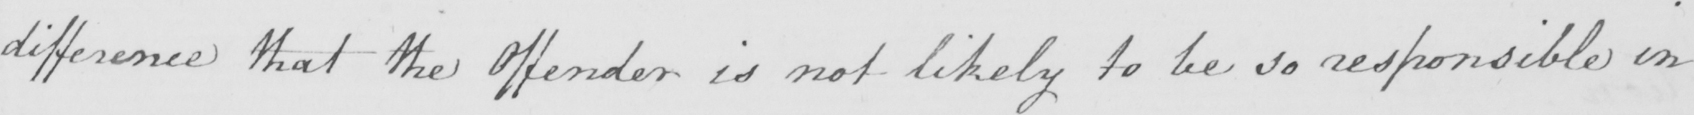What does this handwritten line say? difference that the Offender is not likely to be so responsible in 